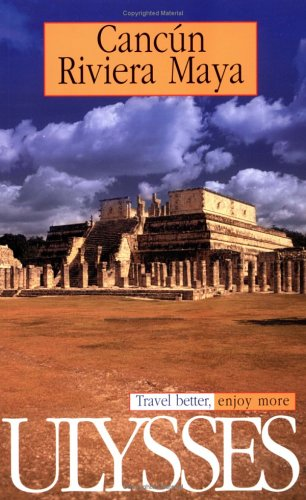Who is the author of this book? The book cover attributes the publishing house 'Ulysses Press' as the 'author', a common practice for some types of guides and reference materials. 